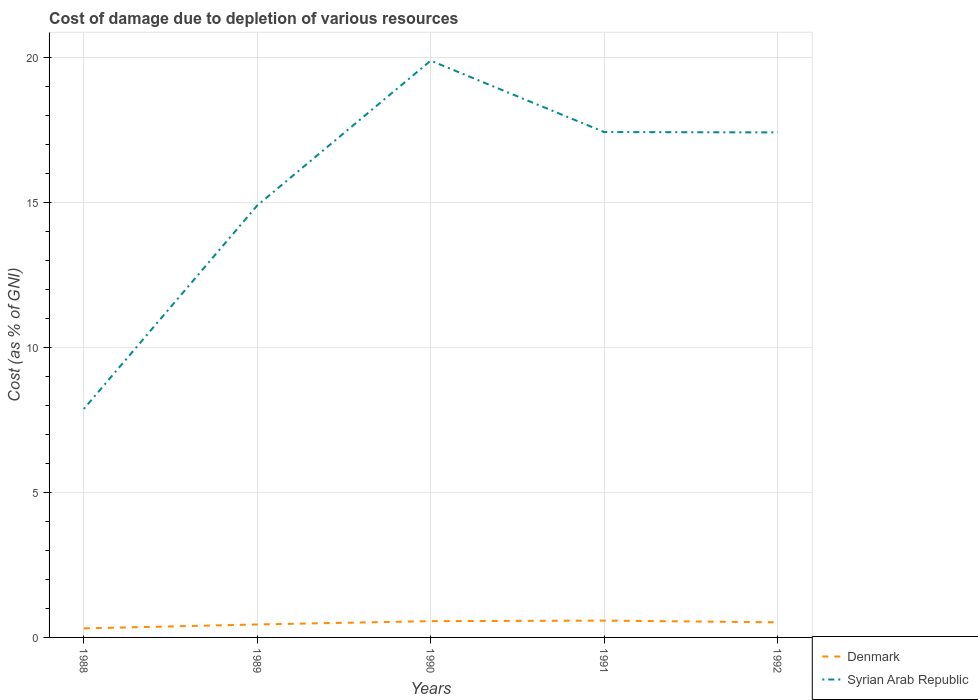Across all years, what is the maximum cost of damage caused due to the depletion of various resources in Syrian Arab Republic?
Keep it short and to the point. 7.88. What is the total cost of damage caused due to the depletion of various resources in Denmark in the graph?
Your answer should be compact. -0.21. What is the difference between the highest and the second highest cost of damage caused due to the depletion of various resources in Denmark?
Offer a terse response. 0.27. What is the difference between the highest and the lowest cost of damage caused due to the depletion of various resources in Syrian Arab Republic?
Your answer should be compact. 3. How many years are there in the graph?
Give a very brief answer. 5. How many legend labels are there?
Your answer should be compact. 2. What is the title of the graph?
Provide a succinct answer. Cost of damage due to depletion of various resources. Does "Iran" appear as one of the legend labels in the graph?
Your answer should be very brief. No. What is the label or title of the Y-axis?
Your answer should be very brief. Cost (as % of GNI). What is the Cost (as % of GNI) of Denmark in 1988?
Offer a very short reply. 0.31. What is the Cost (as % of GNI) in Syrian Arab Republic in 1988?
Provide a short and direct response. 7.88. What is the Cost (as % of GNI) of Denmark in 1989?
Keep it short and to the point. 0.45. What is the Cost (as % of GNI) of Syrian Arab Republic in 1989?
Offer a terse response. 14.89. What is the Cost (as % of GNI) of Denmark in 1990?
Ensure brevity in your answer.  0.56. What is the Cost (as % of GNI) in Syrian Arab Republic in 1990?
Your answer should be very brief. 19.89. What is the Cost (as % of GNI) in Denmark in 1991?
Give a very brief answer. 0.58. What is the Cost (as % of GNI) in Syrian Arab Republic in 1991?
Offer a very short reply. 17.42. What is the Cost (as % of GNI) in Denmark in 1992?
Give a very brief answer. 0.52. What is the Cost (as % of GNI) in Syrian Arab Republic in 1992?
Keep it short and to the point. 17.41. Across all years, what is the maximum Cost (as % of GNI) in Denmark?
Offer a terse response. 0.58. Across all years, what is the maximum Cost (as % of GNI) of Syrian Arab Republic?
Make the answer very short. 19.89. Across all years, what is the minimum Cost (as % of GNI) of Denmark?
Give a very brief answer. 0.31. Across all years, what is the minimum Cost (as % of GNI) in Syrian Arab Republic?
Offer a terse response. 7.88. What is the total Cost (as % of GNI) of Denmark in the graph?
Your response must be concise. 2.42. What is the total Cost (as % of GNI) in Syrian Arab Republic in the graph?
Ensure brevity in your answer.  77.49. What is the difference between the Cost (as % of GNI) in Denmark in 1988 and that in 1989?
Your answer should be very brief. -0.14. What is the difference between the Cost (as % of GNI) of Syrian Arab Republic in 1988 and that in 1989?
Your response must be concise. -7.02. What is the difference between the Cost (as % of GNI) of Denmark in 1988 and that in 1990?
Your answer should be compact. -0.25. What is the difference between the Cost (as % of GNI) of Syrian Arab Republic in 1988 and that in 1990?
Offer a terse response. -12.01. What is the difference between the Cost (as % of GNI) in Denmark in 1988 and that in 1991?
Your answer should be compact. -0.27. What is the difference between the Cost (as % of GNI) of Syrian Arab Republic in 1988 and that in 1991?
Your answer should be very brief. -9.55. What is the difference between the Cost (as % of GNI) of Denmark in 1988 and that in 1992?
Your response must be concise. -0.21. What is the difference between the Cost (as % of GNI) of Syrian Arab Republic in 1988 and that in 1992?
Offer a very short reply. -9.53. What is the difference between the Cost (as % of GNI) of Denmark in 1989 and that in 1990?
Give a very brief answer. -0.11. What is the difference between the Cost (as % of GNI) of Syrian Arab Republic in 1989 and that in 1990?
Offer a very short reply. -4.99. What is the difference between the Cost (as % of GNI) of Denmark in 1989 and that in 1991?
Keep it short and to the point. -0.13. What is the difference between the Cost (as % of GNI) in Syrian Arab Republic in 1989 and that in 1991?
Ensure brevity in your answer.  -2.53. What is the difference between the Cost (as % of GNI) of Denmark in 1989 and that in 1992?
Offer a terse response. -0.07. What is the difference between the Cost (as % of GNI) in Syrian Arab Republic in 1989 and that in 1992?
Offer a terse response. -2.52. What is the difference between the Cost (as % of GNI) in Denmark in 1990 and that in 1991?
Your answer should be compact. -0.02. What is the difference between the Cost (as % of GNI) in Syrian Arab Republic in 1990 and that in 1991?
Give a very brief answer. 2.46. What is the difference between the Cost (as % of GNI) of Denmark in 1990 and that in 1992?
Your answer should be very brief. 0.04. What is the difference between the Cost (as % of GNI) in Syrian Arab Republic in 1990 and that in 1992?
Provide a short and direct response. 2.47. What is the difference between the Cost (as % of GNI) in Denmark in 1991 and that in 1992?
Make the answer very short. 0.06. What is the difference between the Cost (as % of GNI) of Syrian Arab Republic in 1991 and that in 1992?
Provide a succinct answer. 0.01. What is the difference between the Cost (as % of GNI) of Denmark in 1988 and the Cost (as % of GNI) of Syrian Arab Republic in 1989?
Ensure brevity in your answer.  -14.58. What is the difference between the Cost (as % of GNI) of Denmark in 1988 and the Cost (as % of GNI) of Syrian Arab Republic in 1990?
Offer a very short reply. -19.57. What is the difference between the Cost (as % of GNI) in Denmark in 1988 and the Cost (as % of GNI) in Syrian Arab Republic in 1991?
Your answer should be compact. -17.11. What is the difference between the Cost (as % of GNI) of Denmark in 1988 and the Cost (as % of GNI) of Syrian Arab Republic in 1992?
Make the answer very short. -17.1. What is the difference between the Cost (as % of GNI) of Denmark in 1989 and the Cost (as % of GNI) of Syrian Arab Republic in 1990?
Offer a terse response. -19.44. What is the difference between the Cost (as % of GNI) in Denmark in 1989 and the Cost (as % of GNI) in Syrian Arab Republic in 1991?
Provide a succinct answer. -16.98. What is the difference between the Cost (as % of GNI) of Denmark in 1989 and the Cost (as % of GNI) of Syrian Arab Republic in 1992?
Your answer should be very brief. -16.96. What is the difference between the Cost (as % of GNI) in Denmark in 1990 and the Cost (as % of GNI) in Syrian Arab Republic in 1991?
Provide a short and direct response. -16.86. What is the difference between the Cost (as % of GNI) in Denmark in 1990 and the Cost (as % of GNI) in Syrian Arab Republic in 1992?
Provide a succinct answer. -16.85. What is the difference between the Cost (as % of GNI) of Denmark in 1991 and the Cost (as % of GNI) of Syrian Arab Republic in 1992?
Give a very brief answer. -16.83. What is the average Cost (as % of GNI) of Denmark per year?
Give a very brief answer. 0.48. What is the average Cost (as % of GNI) of Syrian Arab Republic per year?
Offer a very short reply. 15.5. In the year 1988, what is the difference between the Cost (as % of GNI) in Denmark and Cost (as % of GNI) in Syrian Arab Republic?
Offer a very short reply. -7.57. In the year 1989, what is the difference between the Cost (as % of GNI) in Denmark and Cost (as % of GNI) in Syrian Arab Republic?
Give a very brief answer. -14.45. In the year 1990, what is the difference between the Cost (as % of GNI) of Denmark and Cost (as % of GNI) of Syrian Arab Republic?
Offer a terse response. -19.32. In the year 1991, what is the difference between the Cost (as % of GNI) of Denmark and Cost (as % of GNI) of Syrian Arab Republic?
Provide a short and direct response. -16.84. In the year 1992, what is the difference between the Cost (as % of GNI) of Denmark and Cost (as % of GNI) of Syrian Arab Republic?
Your answer should be very brief. -16.89. What is the ratio of the Cost (as % of GNI) in Denmark in 1988 to that in 1989?
Offer a very short reply. 0.7. What is the ratio of the Cost (as % of GNI) in Syrian Arab Republic in 1988 to that in 1989?
Provide a succinct answer. 0.53. What is the ratio of the Cost (as % of GNI) of Denmark in 1988 to that in 1990?
Your answer should be compact. 0.56. What is the ratio of the Cost (as % of GNI) in Syrian Arab Republic in 1988 to that in 1990?
Your answer should be compact. 0.4. What is the ratio of the Cost (as % of GNI) of Denmark in 1988 to that in 1991?
Your answer should be compact. 0.54. What is the ratio of the Cost (as % of GNI) in Syrian Arab Republic in 1988 to that in 1991?
Make the answer very short. 0.45. What is the ratio of the Cost (as % of GNI) in Denmark in 1988 to that in 1992?
Provide a succinct answer. 0.6. What is the ratio of the Cost (as % of GNI) of Syrian Arab Republic in 1988 to that in 1992?
Offer a very short reply. 0.45. What is the ratio of the Cost (as % of GNI) of Denmark in 1989 to that in 1990?
Your response must be concise. 0.8. What is the ratio of the Cost (as % of GNI) in Syrian Arab Republic in 1989 to that in 1990?
Give a very brief answer. 0.75. What is the ratio of the Cost (as % of GNI) of Denmark in 1989 to that in 1991?
Provide a short and direct response. 0.77. What is the ratio of the Cost (as % of GNI) in Syrian Arab Republic in 1989 to that in 1991?
Offer a very short reply. 0.85. What is the ratio of the Cost (as % of GNI) of Denmark in 1989 to that in 1992?
Give a very brief answer. 0.86. What is the ratio of the Cost (as % of GNI) in Syrian Arab Republic in 1989 to that in 1992?
Your answer should be compact. 0.86. What is the ratio of the Cost (as % of GNI) in Denmark in 1990 to that in 1991?
Provide a succinct answer. 0.97. What is the ratio of the Cost (as % of GNI) of Syrian Arab Republic in 1990 to that in 1991?
Your response must be concise. 1.14. What is the ratio of the Cost (as % of GNI) in Denmark in 1990 to that in 1992?
Your answer should be very brief. 1.08. What is the ratio of the Cost (as % of GNI) of Syrian Arab Republic in 1990 to that in 1992?
Your answer should be compact. 1.14. What is the ratio of the Cost (as % of GNI) of Denmark in 1991 to that in 1992?
Your response must be concise. 1.11. What is the difference between the highest and the second highest Cost (as % of GNI) in Denmark?
Ensure brevity in your answer.  0.02. What is the difference between the highest and the second highest Cost (as % of GNI) of Syrian Arab Republic?
Keep it short and to the point. 2.46. What is the difference between the highest and the lowest Cost (as % of GNI) of Denmark?
Your answer should be compact. 0.27. What is the difference between the highest and the lowest Cost (as % of GNI) of Syrian Arab Republic?
Provide a succinct answer. 12.01. 